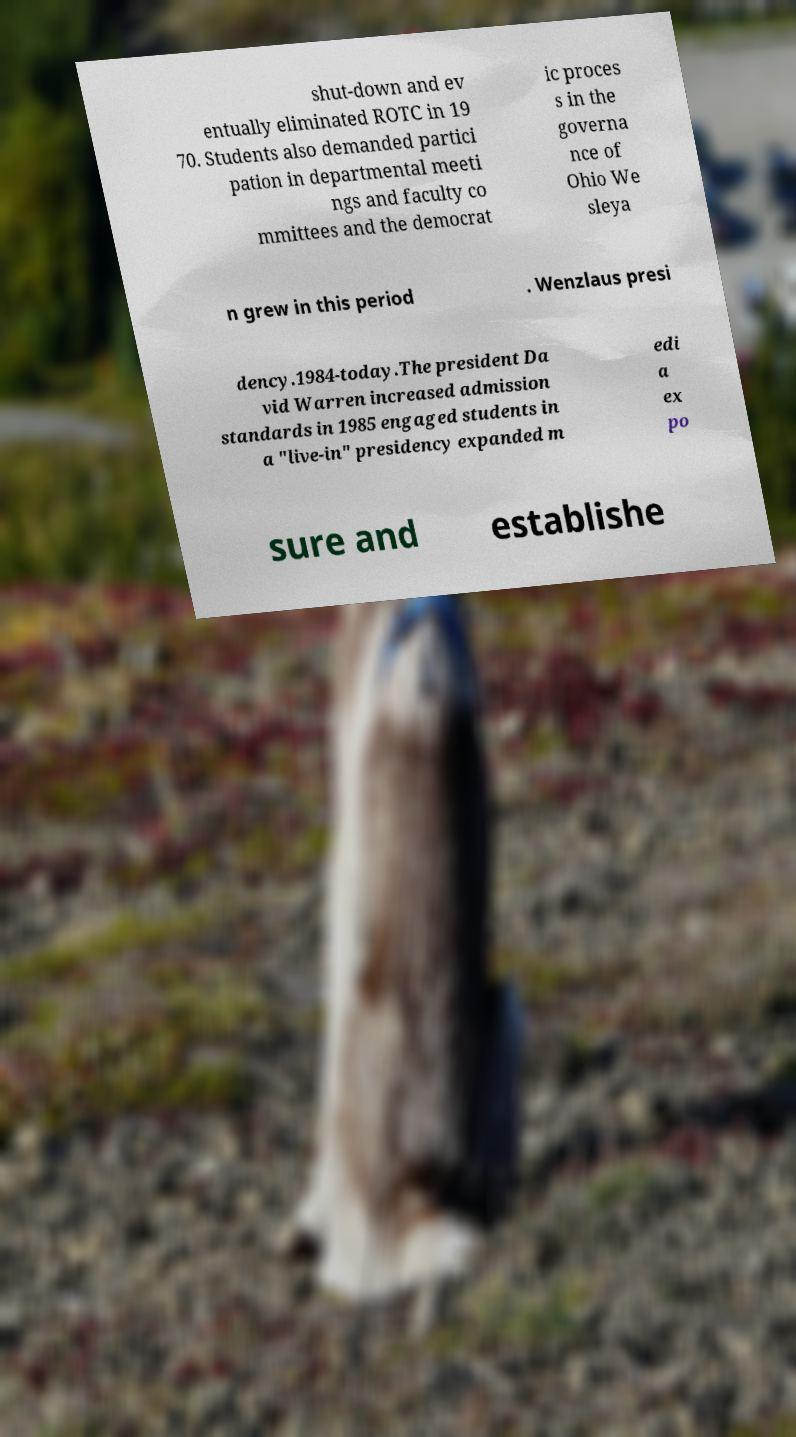Can you read and provide the text displayed in the image?This photo seems to have some interesting text. Can you extract and type it out for me? shut-down and ev entually eliminated ROTC in 19 70. Students also demanded partici pation in departmental meeti ngs and faculty co mmittees and the democrat ic proces s in the governa nce of Ohio We sleya n grew in this period . Wenzlaus presi dency.1984-today.The president Da vid Warren increased admission standards in 1985 engaged students in a "live-in" presidency expanded m edi a ex po sure and establishe 